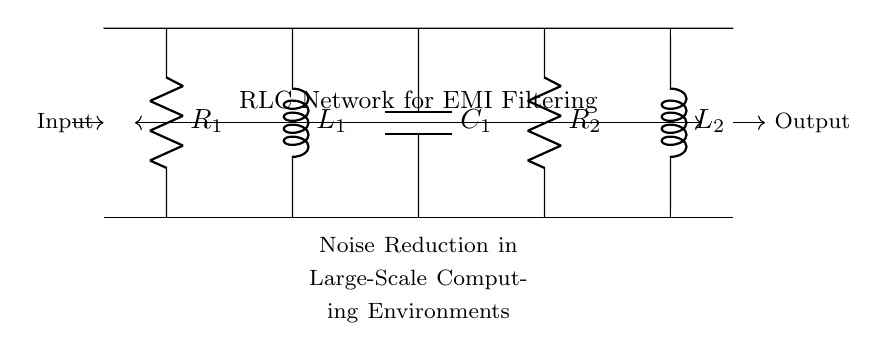What is the total number of components in this RLC network? The diagram shows two resistors, two inductors, and one capacitor, which sums up to a total of five components.
Answer: five What are the values of the inductors in this circuit? The circuit specifies two inductors labeled L1 and L2. However, the exact values of L1 and L2 are not indicated in this representation.
Answer: unspecified How is the RLC network connected between the input and output? The drawing illustrates a series connection of components where the input flows from left to right through the resistors, inductors, and capacitor before reaching the output.
Answer: series connection Which component is responsible for filtering out high-frequency noise? In an RLC circuit, the capacitor typically serves to filter out high-frequency noise by providing a low impedance path for AC signals, while blocking DC signals.
Answer: capacitor What type of noise reduction mechanism do RLC networks provide? RLC networks employ a resonant behavior that selectively attenuates noise frequencies while allowing useful signals to pass through unimpeded, leading to improved signal integrity.
Answer: resonant behavior What is the function of the resistor in this RLC network? Resistors in RLC circuits primarily provide damping to reduce oscillations caused by the LC components, helping to stabilize the circuit and prevent unintended resonances.
Answer: damping How many resistance elements are present in this circuit? The circuit includes two distinct resistors, labeled as R1 and R2, which are critical for adjusting the circuit's damping characteristics.
Answer: two 